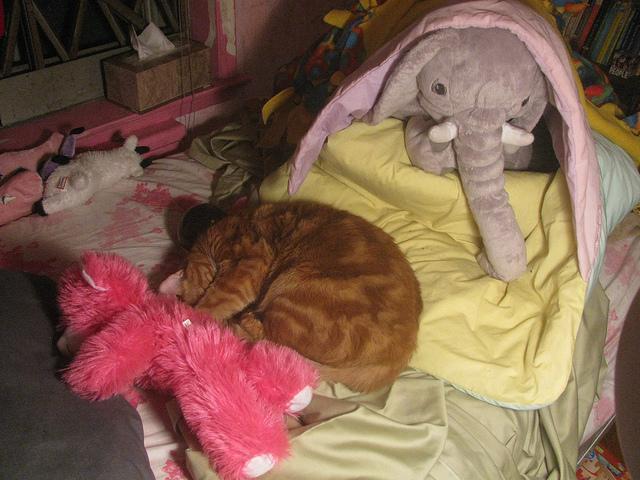How many people in this image are wearing red hats?
Give a very brief answer. 0. 